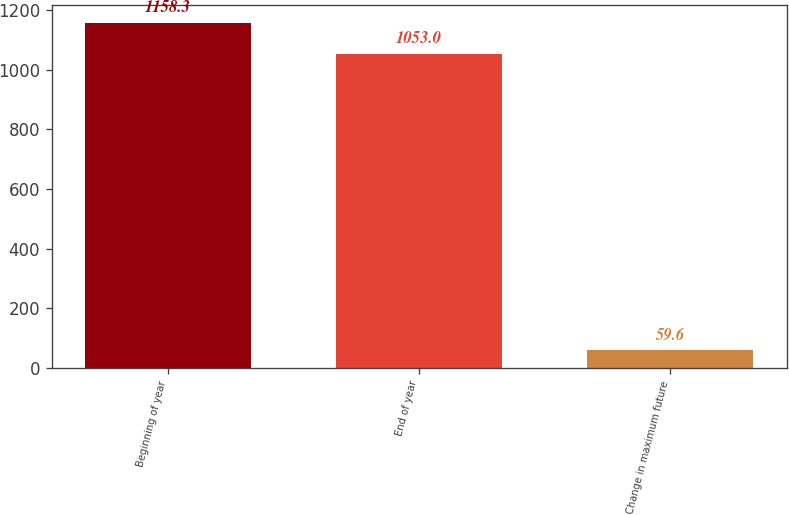<chart> <loc_0><loc_0><loc_500><loc_500><bar_chart><fcel>Beginning of year<fcel>End of year<fcel>Change in maximum future<nl><fcel>1158.3<fcel>1053<fcel>59.6<nl></chart> 